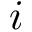<formula> <loc_0><loc_0><loc_500><loc_500>i</formula> 